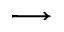<formula> <loc_0><loc_0><loc_500><loc_500>\longrightarrow</formula> 